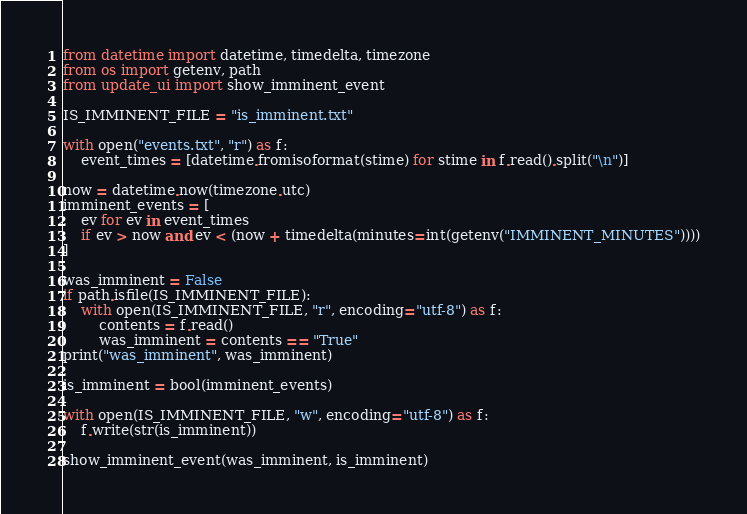Convert code to text. <code><loc_0><loc_0><loc_500><loc_500><_Python_>from datetime import datetime, timedelta, timezone
from os import getenv, path
from update_ui import show_imminent_event

IS_IMMINENT_FILE = "is_imminent.txt"

with open("events.txt", "r") as f:
    event_times = [datetime.fromisoformat(stime) for stime in f.read().split("\n")]

now = datetime.now(timezone.utc)
imminent_events = [
    ev for ev in event_times
    if ev > now and ev < (now + timedelta(minutes=int(getenv("IMMINENT_MINUTES"))))
]

was_imminent = False
if path.isfile(IS_IMMINENT_FILE):
    with open(IS_IMMINENT_FILE, "r", encoding="utf-8") as f:
        contents = f.read()
        was_imminent = contents == "True"
print("was_imminent", was_imminent)

is_imminent = bool(imminent_events)

with open(IS_IMMINENT_FILE, "w", encoding="utf-8") as f:
    f.write(str(is_imminent))

show_imminent_event(was_imminent, is_imminent)
</code> 